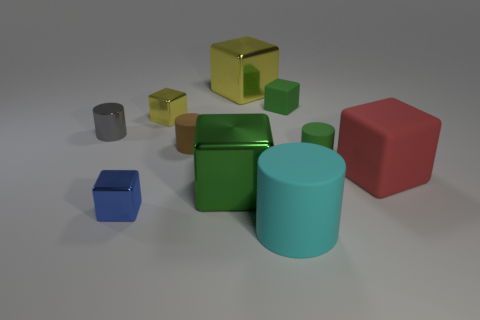Subtract all shiny cylinders. How many cylinders are left? 3 Subtract all green cylinders. How many cylinders are left? 3 Subtract all brown cylinders. Subtract all cyan spheres. How many cylinders are left? 3 Subtract all brown spheres. How many yellow blocks are left? 2 Subtract all large red matte objects. Subtract all blue blocks. How many objects are left? 8 Add 1 big green blocks. How many big green blocks are left? 2 Add 5 gray objects. How many gray objects exist? 6 Subtract 0 yellow cylinders. How many objects are left? 10 Subtract all cylinders. How many objects are left? 6 Subtract 3 blocks. How many blocks are left? 3 